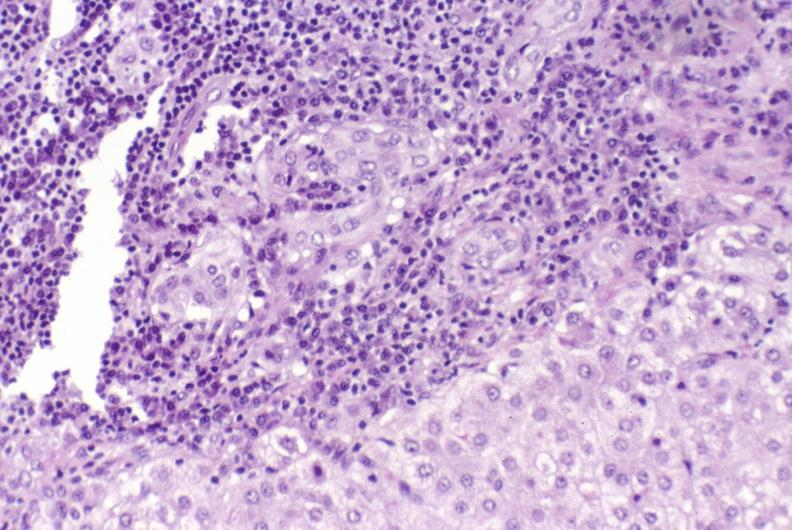s temporal muscle hemorrhage present?
Answer the question using a single word or phrase. No 